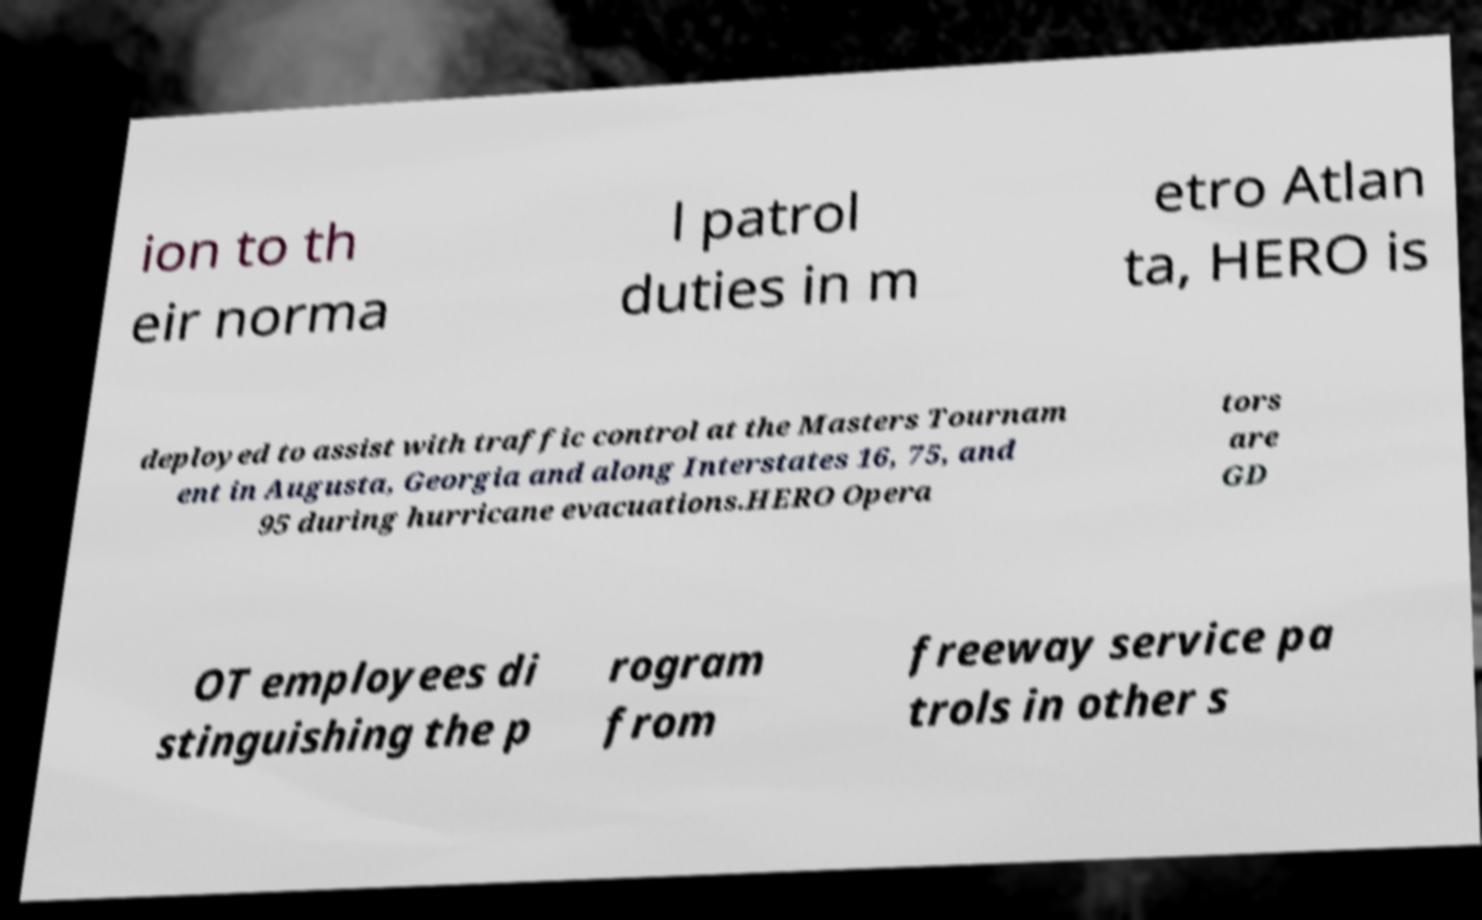Please read and relay the text visible in this image. What does it say? ion to th eir norma l patrol duties in m etro Atlan ta, HERO is deployed to assist with traffic control at the Masters Tournam ent in Augusta, Georgia and along Interstates 16, 75, and 95 during hurricane evacuations.HERO Opera tors are GD OT employees di stinguishing the p rogram from freeway service pa trols in other s 